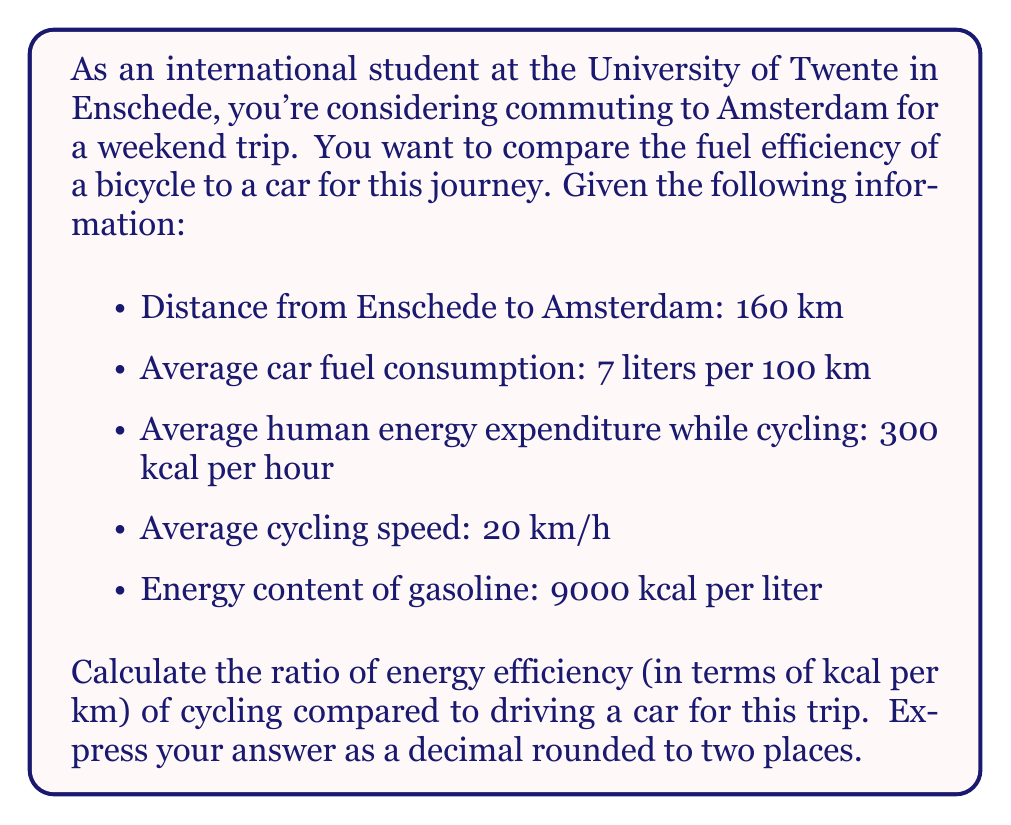Teach me how to tackle this problem. Let's approach this problem step by step:

1. Calculate the energy used by the car:
   - Distance = 160 km
   - Fuel consumed = $160 \text{ km} \times \frac{7 \text{ L}}{100 \text{ km}} = 11.2 \text{ L}$
   - Energy used by car = $11.2 \text{ L} \times 9000 \frac{\text{kcal}}{\text{L}} = 100,800 \text{ kcal}$

2. Calculate the energy used by cycling:
   - Time taken = $\frac{160 \text{ km}}{20 \text{ km/h}} = 8 \text{ hours}$
   - Energy used by cycling = $8 \text{ hours} \times 300 \frac{\text{kcal}}{\text{hour}} = 2,400 \text{ kcal}$

3. Calculate energy efficiency (kcal per km) for both:
   - Car efficiency = $\frac{100,800 \text{ kcal}}{160 \text{ km}} = 630 \frac{\text{kcal}}{\text{km}}$
   - Cycling efficiency = $\frac{2,400 \text{ kcal}}{160 \text{ km}} = 15 \frac{\text{kcal}}{\text{km}}$

4. Calculate the ratio of cycling efficiency to car efficiency:
   $$\text{Ratio} = \frac{\text{Cycling efficiency}}{\text{Car efficiency}} = \frac{15}{630} = 0.0238$$

Rounding to two decimal places, we get 0.02.
Answer: 0.02 